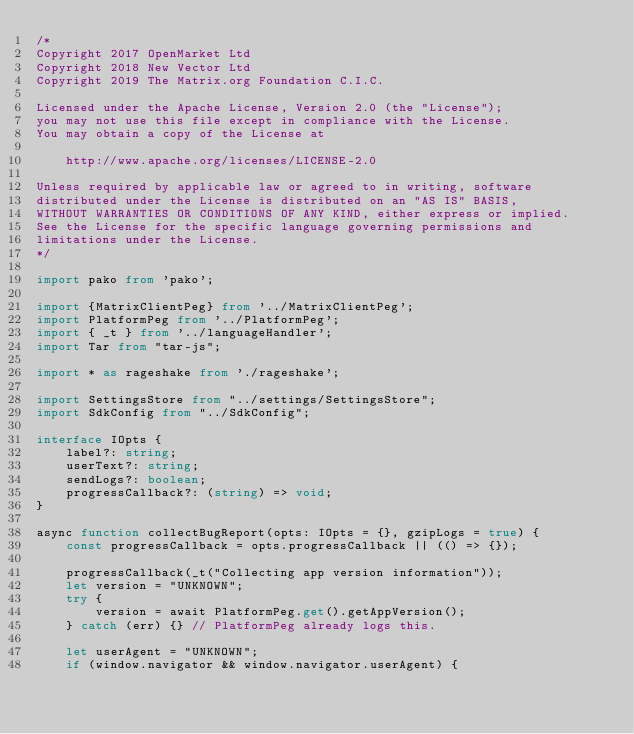<code> <loc_0><loc_0><loc_500><loc_500><_TypeScript_>/*
Copyright 2017 OpenMarket Ltd
Copyright 2018 New Vector Ltd
Copyright 2019 The Matrix.org Foundation C.I.C.

Licensed under the Apache License, Version 2.0 (the "License");
you may not use this file except in compliance with the License.
You may obtain a copy of the License at

    http://www.apache.org/licenses/LICENSE-2.0

Unless required by applicable law or agreed to in writing, software
distributed under the License is distributed on an "AS IS" BASIS,
WITHOUT WARRANTIES OR CONDITIONS OF ANY KIND, either express or implied.
See the License for the specific language governing permissions and
limitations under the License.
*/

import pako from 'pako';

import {MatrixClientPeg} from '../MatrixClientPeg';
import PlatformPeg from '../PlatformPeg';
import { _t } from '../languageHandler';
import Tar from "tar-js";

import * as rageshake from './rageshake';

import SettingsStore from "../settings/SettingsStore";
import SdkConfig from "../SdkConfig";

interface IOpts {
    label?: string;
    userText?: string;
    sendLogs?: boolean;
    progressCallback?: (string) => void;
}

async function collectBugReport(opts: IOpts = {}, gzipLogs = true) {
    const progressCallback = opts.progressCallback || (() => {});

    progressCallback(_t("Collecting app version information"));
    let version = "UNKNOWN";
    try {
        version = await PlatformPeg.get().getAppVersion();
    } catch (err) {} // PlatformPeg already logs this.

    let userAgent = "UNKNOWN";
    if (window.navigator && window.navigator.userAgent) {</code> 